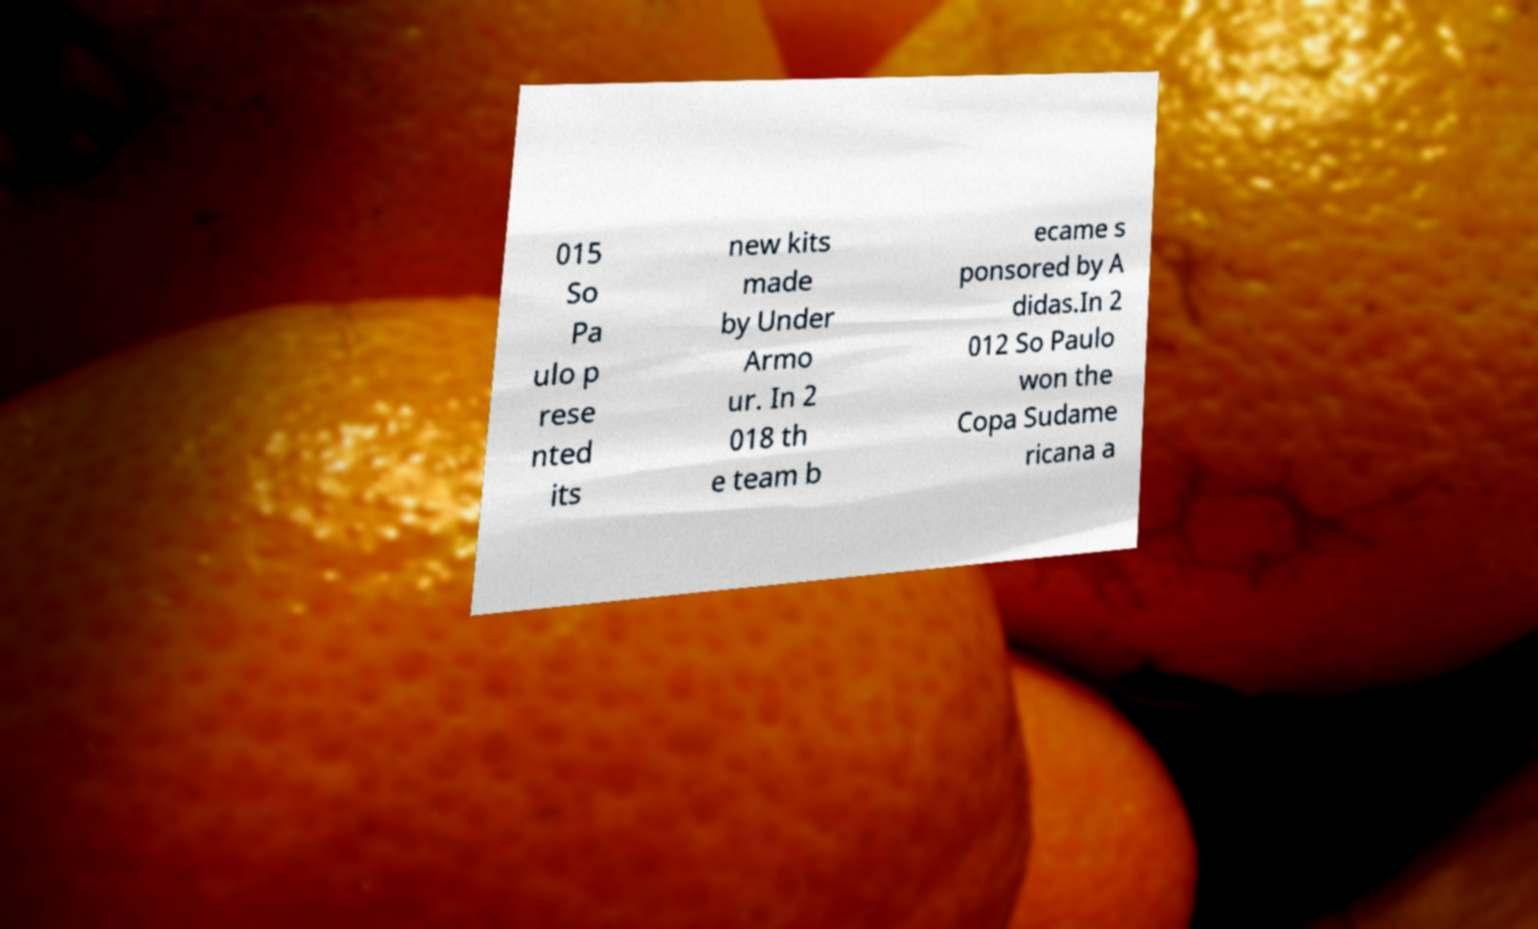There's text embedded in this image that I need extracted. Can you transcribe it verbatim? 015 So Pa ulo p rese nted its new kits made by Under Armo ur. In 2 018 th e team b ecame s ponsored by A didas.In 2 012 So Paulo won the Copa Sudame ricana a 